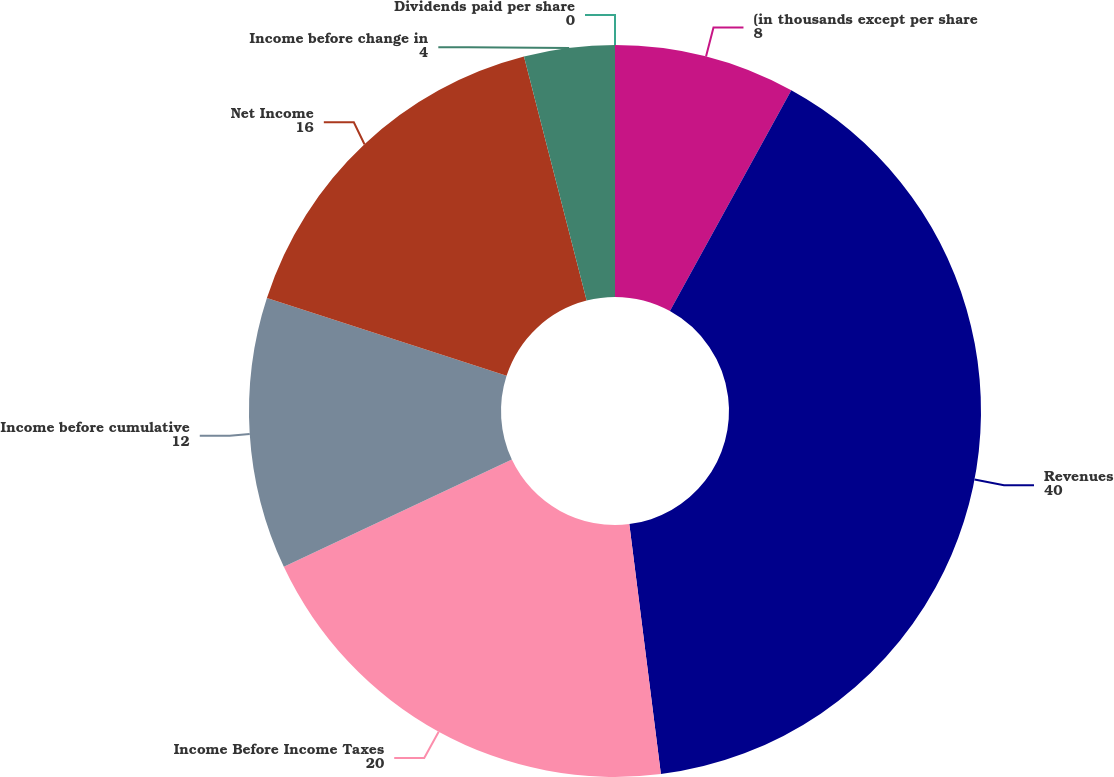Convert chart to OTSL. <chart><loc_0><loc_0><loc_500><loc_500><pie_chart><fcel>(in thousands except per share<fcel>Revenues<fcel>Income Before Income Taxes<fcel>Income before cumulative<fcel>Net Income<fcel>Income before change in<fcel>Dividends paid per share<nl><fcel>8.0%<fcel>40.0%<fcel>20.0%<fcel>12.0%<fcel>16.0%<fcel>4.0%<fcel>0.0%<nl></chart> 